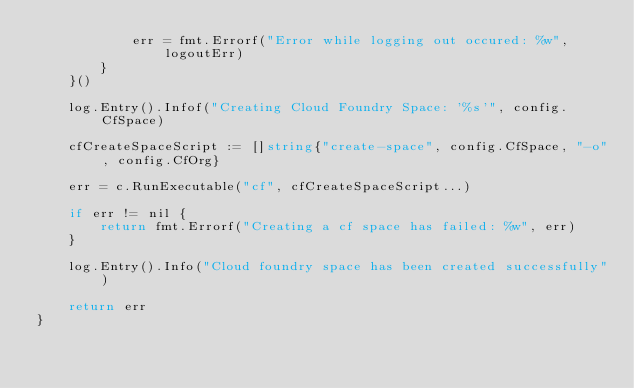Convert code to text. <code><loc_0><loc_0><loc_500><loc_500><_Go_>			err = fmt.Errorf("Error while logging out occured: %w", logoutErr)
		}
	}()

	log.Entry().Infof("Creating Cloud Foundry Space: '%s'", config.CfSpace)

	cfCreateSpaceScript := []string{"create-space", config.CfSpace, "-o", config.CfOrg}

	err = c.RunExecutable("cf", cfCreateSpaceScript...)

	if err != nil {
		return fmt.Errorf("Creating a cf space has failed: %w", err)
	}

	log.Entry().Info("Cloud foundry space has been created successfully")

	return err
}
</code> 